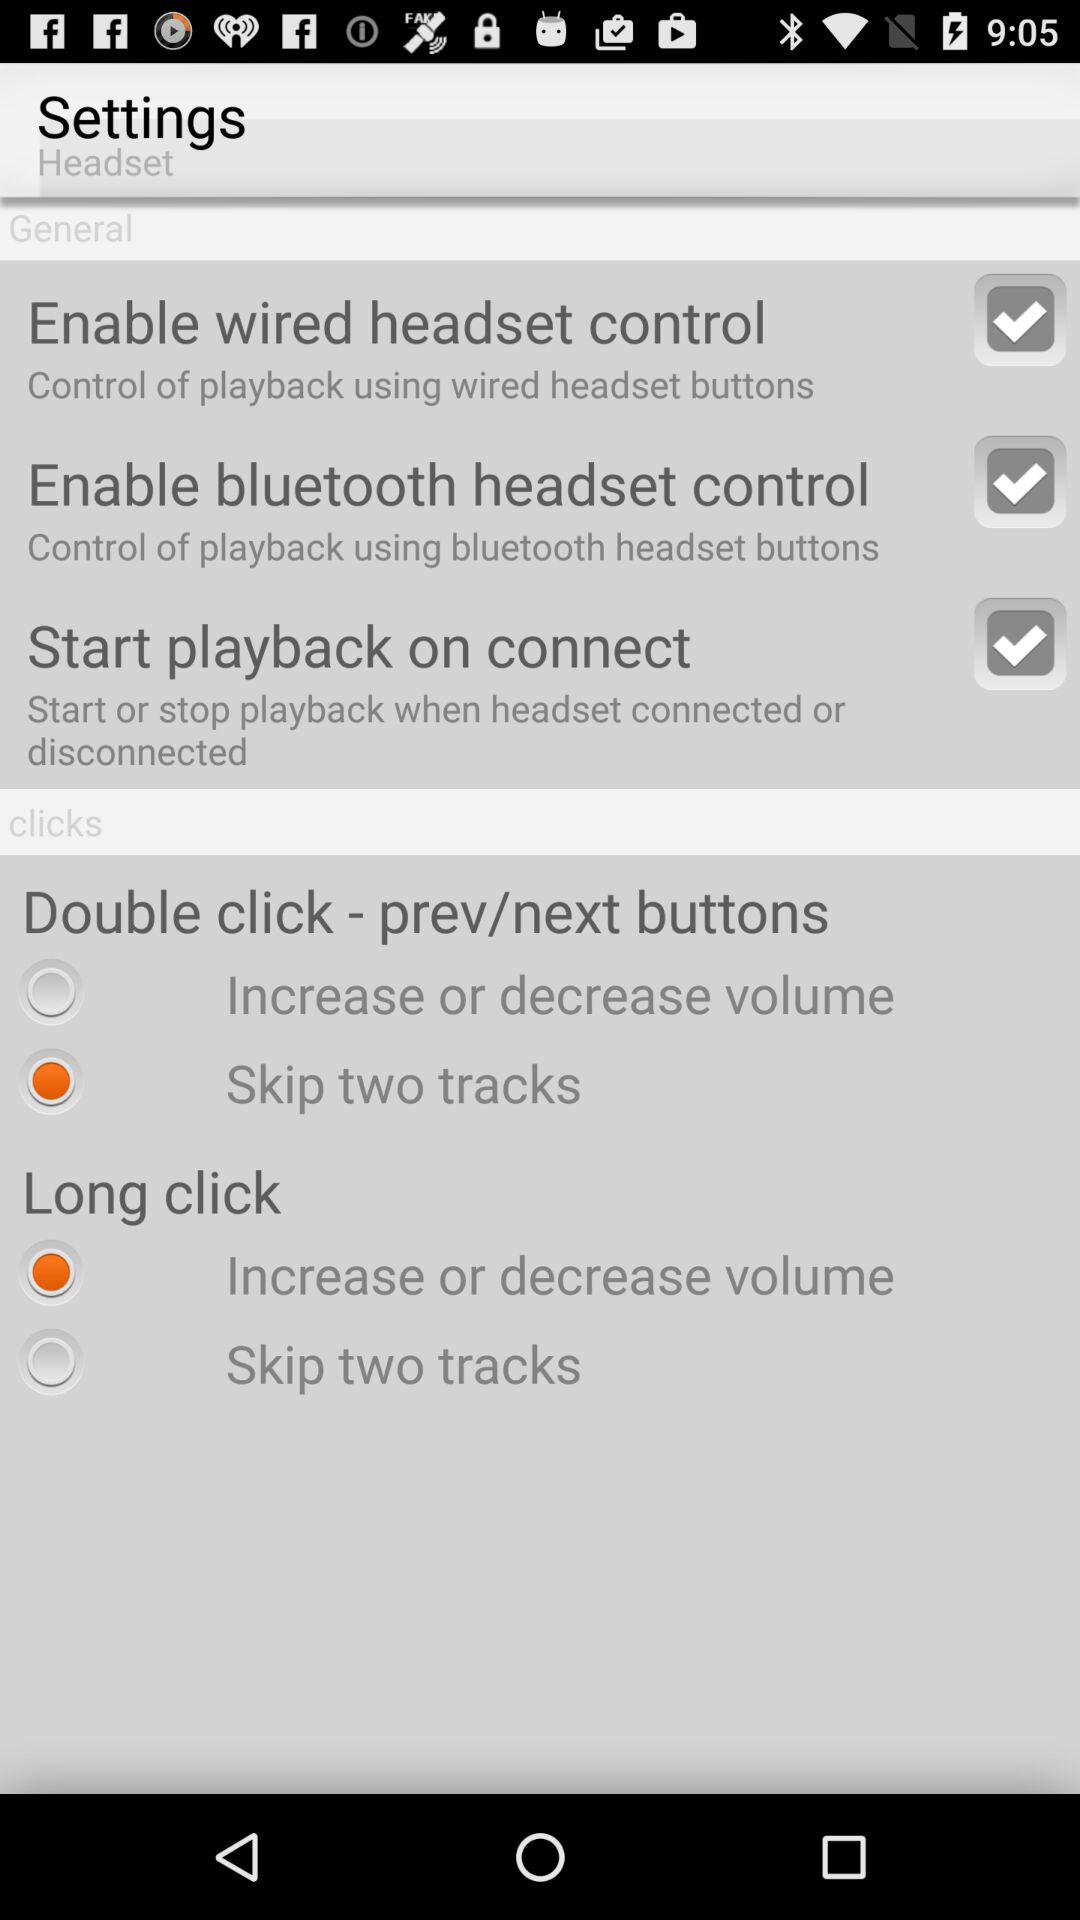Which option has been selected for the "Double click buttons"? The option that has been selected for the "Double click buttons" is "Skip two tracks". 